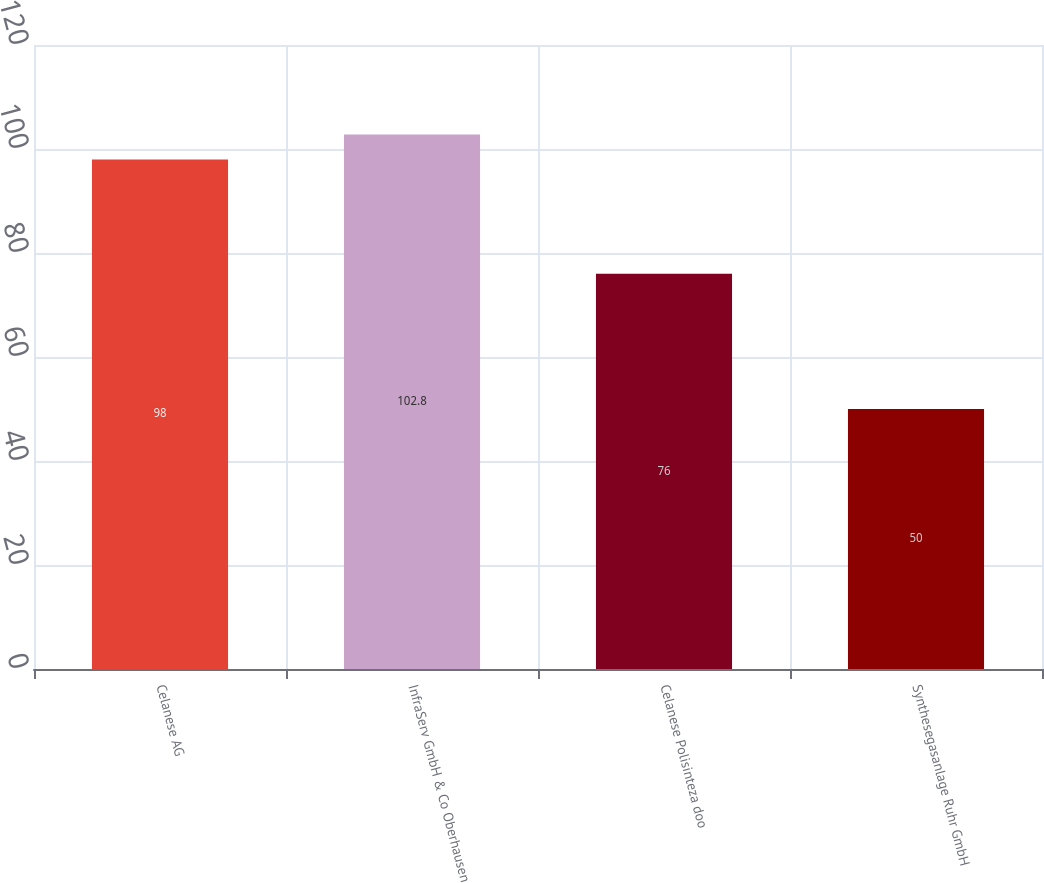Convert chart. <chart><loc_0><loc_0><loc_500><loc_500><bar_chart><fcel>Celanese AG<fcel>InfraServ GmbH & Co Oberhausen<fcel>Celanese Polisinteza doo<fcel>Synthesegasanlage Ruhr GmbH<nl><fcel>98<fcel>102.8<fcel>76<fcel>50<nl></chart> 